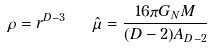Convert formula to latex. <formula><loc_0><loc_0><loc_500><loc_500>\rho = r ^ { D - 3 } \quad \hat { \mu } = { \frac { 1 6 \pi G _ { N } M } { ( D - 2 ) A _ { D - 2 } } }</formula> 